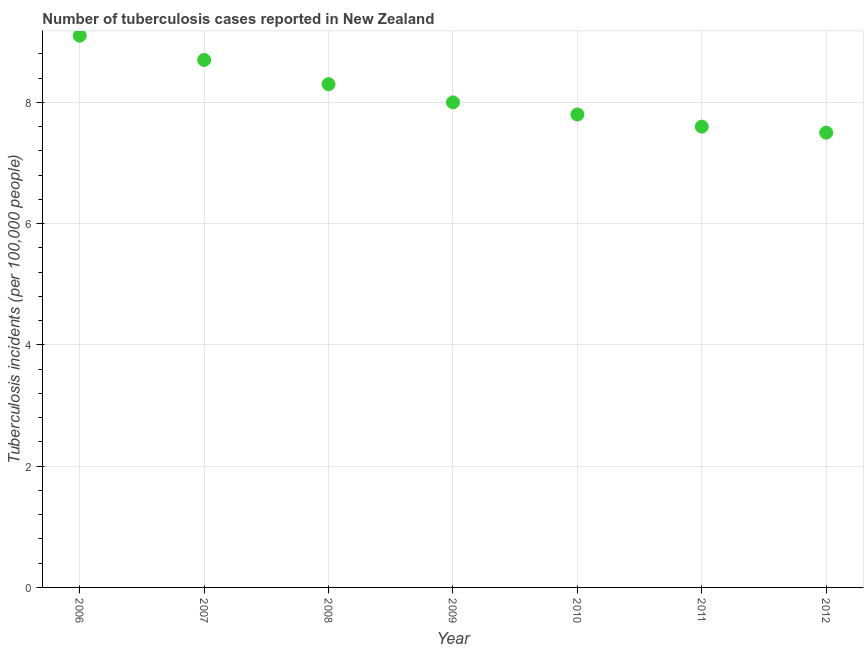In which year was the number of tuberculosis incidents maximum?
Offer a very short reply. 2006. What is the sum of the number of tuberculosis incidents?
Make the answer very short. 57. What is the difference between the number of tuberculosis incidents in 2006 and 2009?
Give a very brief answer. 1.1. What is the average number of tuberculosis incidents per year?
Your answer should be very brief. 8.14. In how many years, is the number of tuberculosis incidents greater than 8.4 ?
Your answer should be very brief. 2. Do a majority of the years between 2010 and 2006 (inclusive) have number of tuberculosis incidents greater than 8.4 ?
Ensure brevity in your answer.  Yes. What is the ratio of the number of tuberculosis incidents in 2009 to that in 2012?
Make the answer very short. 1.07. Is the difference between the number of tuberculosis incidents in 2008 and 2012 greater than the difference between any two years?
Your response must be concise. No. What is the difference between the highest and the second highest number of tuberculosis incidents?
Make the answer very short. 0.4. What is the difference between the highest and the lowest number of tuberculosis incidents?
Give a very brief answer. 1.6. In how many years, is the number of tuberculosis incidents greater than the average number of tuberculosis incidents taken over all years?
Offer a terse response. 3. What is the difference between two consecutive major ticks on the Y-axis?
Provide a succinct answer. 2. Does the graph contain any zero values?
Your answer should be compact. No. What is the title of the graph?
Give a very brief answer. Number of tuberculosis cases reported in New Zealand. What is the label or title of the X-axis?
Provide a succinct answer. Year. What is the label or title of the Y-axis?
Keep it short and to the point. Tuberculosis incidents (per 100,0 people). What is the Tuberculosis incidents (per 100,000 people) in 2010?
Your response must be concise. 7.8. What is the difference between the Tuberculosis incidents (per 100,000 people) in 2006 and 2007?
Offer a terse response. 0.4. What is the difference between the Tuberculosis incidents (per 100,000 people) in 2006 and 2009?
Offer a terse response. 1.1. What is the difference between the Tuberculosis incidents (per 100,000 people) in 2006 and 2011?
Keep it short and to the point. 1.5. What is the difference between the Tuberculosis incidents (per 100,000 people) in 2006 and 2012?
Your answer should be compact. 1.6. What is the difference between the Tuberculosis incidents (per 100,000 people) in 2007 and 2011?
Give a very brief answer. 1.1. What is the difference between the Tuberculosis incidents (per 100,000 people) in 2008 and 2010?
Keep it short and to the point. 0.5. What is the difference between the Tuberculosis incidents (per 100,000 people) in 2008 and 2012?
Give a very brief answer. 0.8. What is the difference between the Tuberculosis incidents (per 100,000 people) in 2009 and 2010?
Give a very brief answer. 0.2. What is the difference between the Tuberculosis incidents (per 100,000 people) in 2009 and 2011?
Your answer should be compact. 0.4. What is the difference between the Tuberculosis incidents (per 100,000 people) in 2010 and 2011?
Offer a very short reply. 0.2. What is the difference between the Tuberculosis incidents (per 100,000 people) in 2010 and 2012?
Offer a very short reply. 0.3. What is the ratio of the Tuberculosis incidents (per 100,000 people) in 2006 to that in 2007?
Ensure brevity in your answer.  1.05. What is the ratio of the Tuberculosis incidents (per 100,000 people) in 2006 to that in 2008?
Give a very brief answer. 1.1. What is the ratio of the Tuberculosis incidents (per 100,000 people) in 2006 to that in 2009?
Make the answer very short. 1.14. What is the ratio of the Tuberculosis incidents (per 100,000 people) in 2006 to that in 2010?
Your answer should be very brief. 1.17. What is the ratio of the Tuberculosis incidents (per 100,000 people) in 2006 to that in 2011?
Your answer should be very brief. 1.2. What is the ratio of the Tuberculosis incidents (per 100,000 people) in 2006 to that in 2012?
Offer a very short reply. 1.21. What is the ratio of the Tuberculosis incidents (per 100,000 people) in 2007 to that in 2008?
Make the answer very short. 1.05. What is the ratio of the Tuberculosis incidents (per 100,000 people) in 2007 to that in 2009?
Offer a very short reply. 1.09. What is the ratio of the Tuberculosis incidents (per 100,000 people) in 2007 to that in 2010?
Keep it short and to the point. 1.11. What is the ratio of the Tuberculosis incidents (per 100,000 people) in 2007 to that in 2011?
Your response must be concise. 1.15. What is the ratio of the Tuberculosis incidents (per 100,000 people) in 2007 to that in 2012?
Provide a short and direct response. 1.16. What is the ratio of the Tuberculosis incidents (per 100,000 people) in 2008 to that in 2009?
Make the answer very short. 1.04. What is the ratio of the Tuberculosis incidents (per 100,000 people) in 2008 to that in 2010?
Ensure brevity in your answer.  1.06. What is the ratio of the Tuberculosis incidents (per 100,000 people) in 2008 to that in 2011?
Offer a terse response. 1.09. What is the ratio of the Tuberculosis incidents (per 100,000 people) in 2008 to that in 2012?
Offer a very short reply. 1.11. What is the ratio of the Tuberculosis incidents (per 100,000 people) in 2009 to that in 2010?
Offer a very short reply. 1.03. What is the ratio of the Tuberculosis incidents (per 100,000 people) in 2009 to that in 2011?
Offer a terse response. 1.05. What is the ratio of the Tuberculosis incidents (per 100,000 people) in 2009 to that in 2012?
Offer a very short reply. 1.07. What is the ratio of the Tuberculosis incidents (per 100,000 people) in 2011 to that in 2012?
Ensure brevity in your answer.  1.01. 